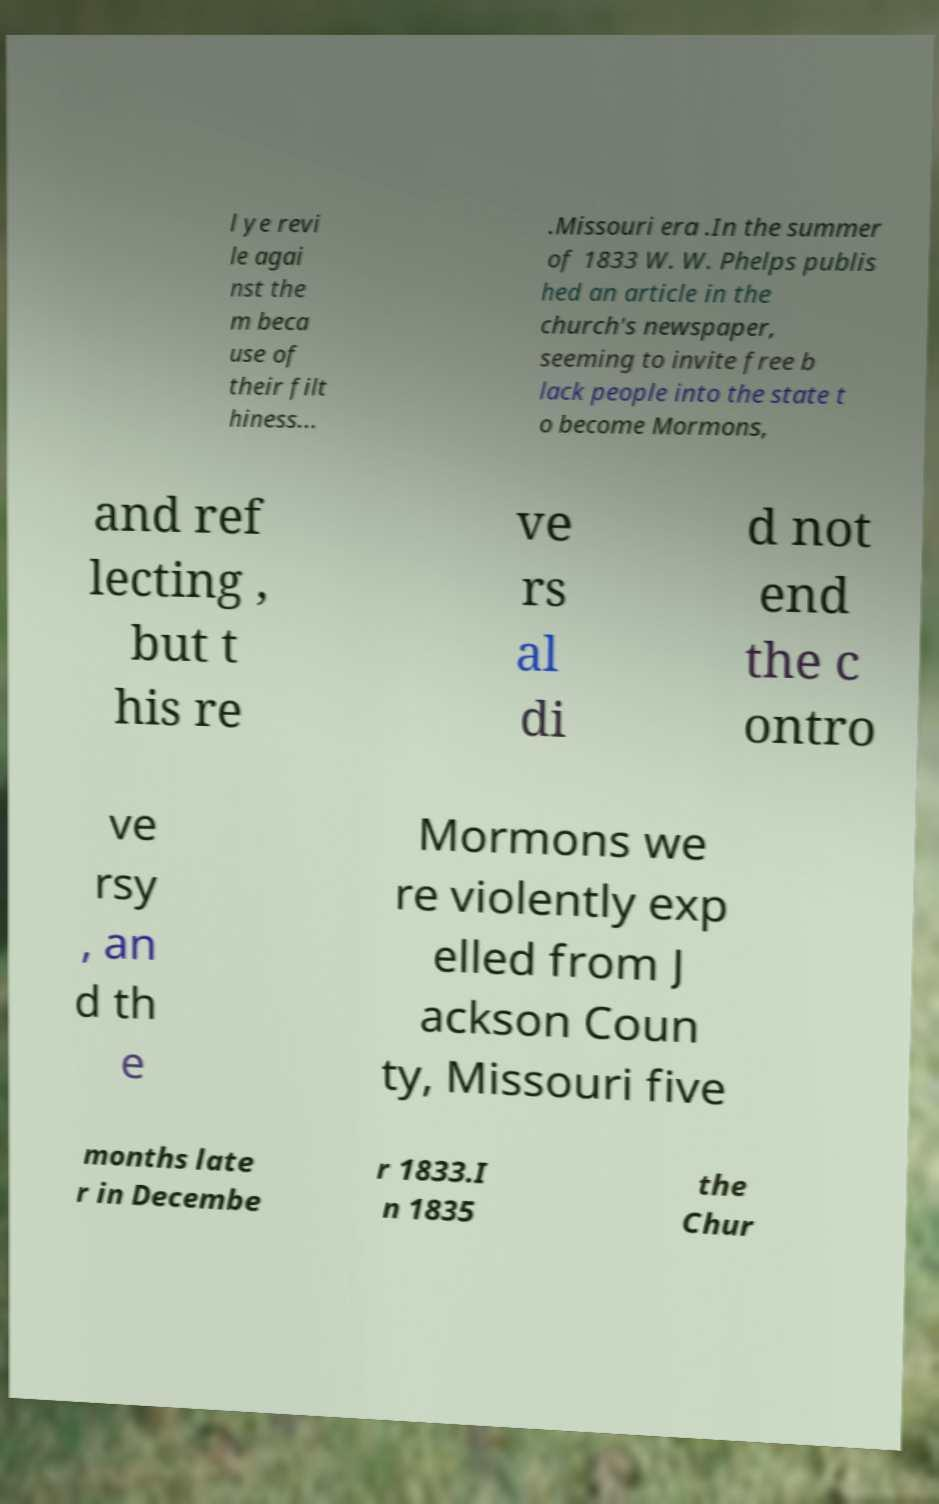There's text embedded in this image that I need extracted. Can you transcribe it verbatim? l ye revi le agai nst the m beca use of their filt hiness... .Missouri era .In the summer of 1833 W. W. Phelps publis hed an article in the church's newspaper, seeming to invite free b lack people into the state t o become Mormons, and ref lecting , but t his re ve rs al di d not end the c ontro ve rsy , an d th e Mormons we re violently exp elled from J ackson Coun ty, Missouri five months late r in Decembe r 1833.I n 1835 the Chur 